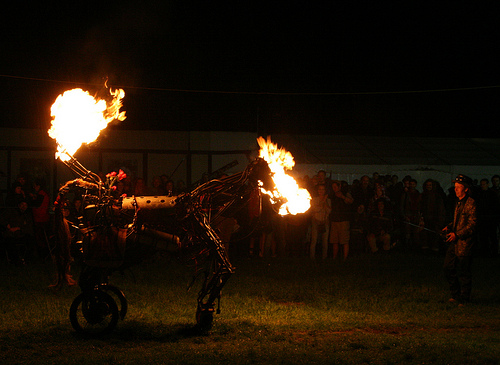<image>
Is there a fire on the ground? No. The fire is not positioned on the ground. They may be near each other, but the fire is not supported by or resting on top of the ground. 